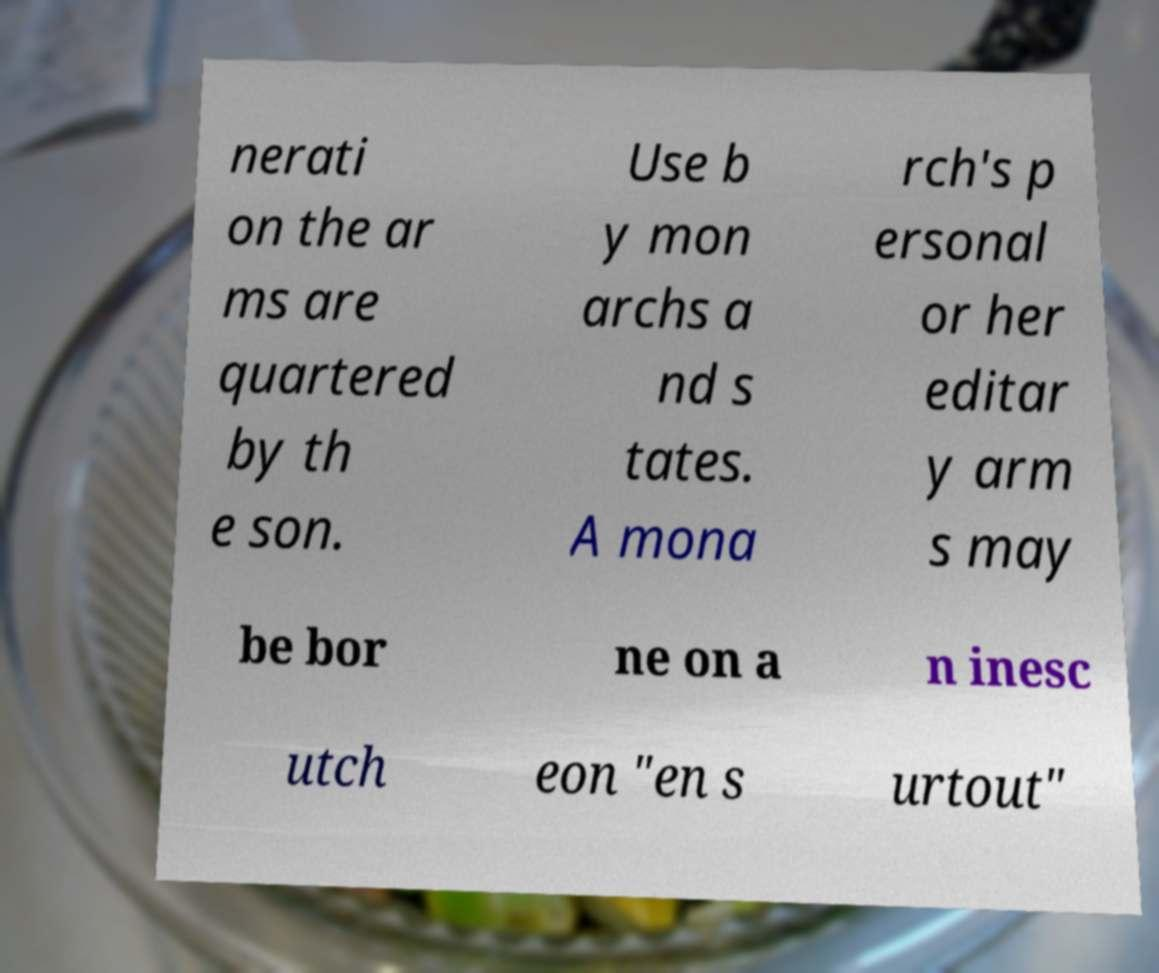Please identify and transcribe the text found in this image. nerati on the ar ms are quartered by th e son. Use b y mon archs a nd s tates. A mona rch's p ersonal or her editar y arm s may be bor ne on a n inesc utch eon "en s urtout" 